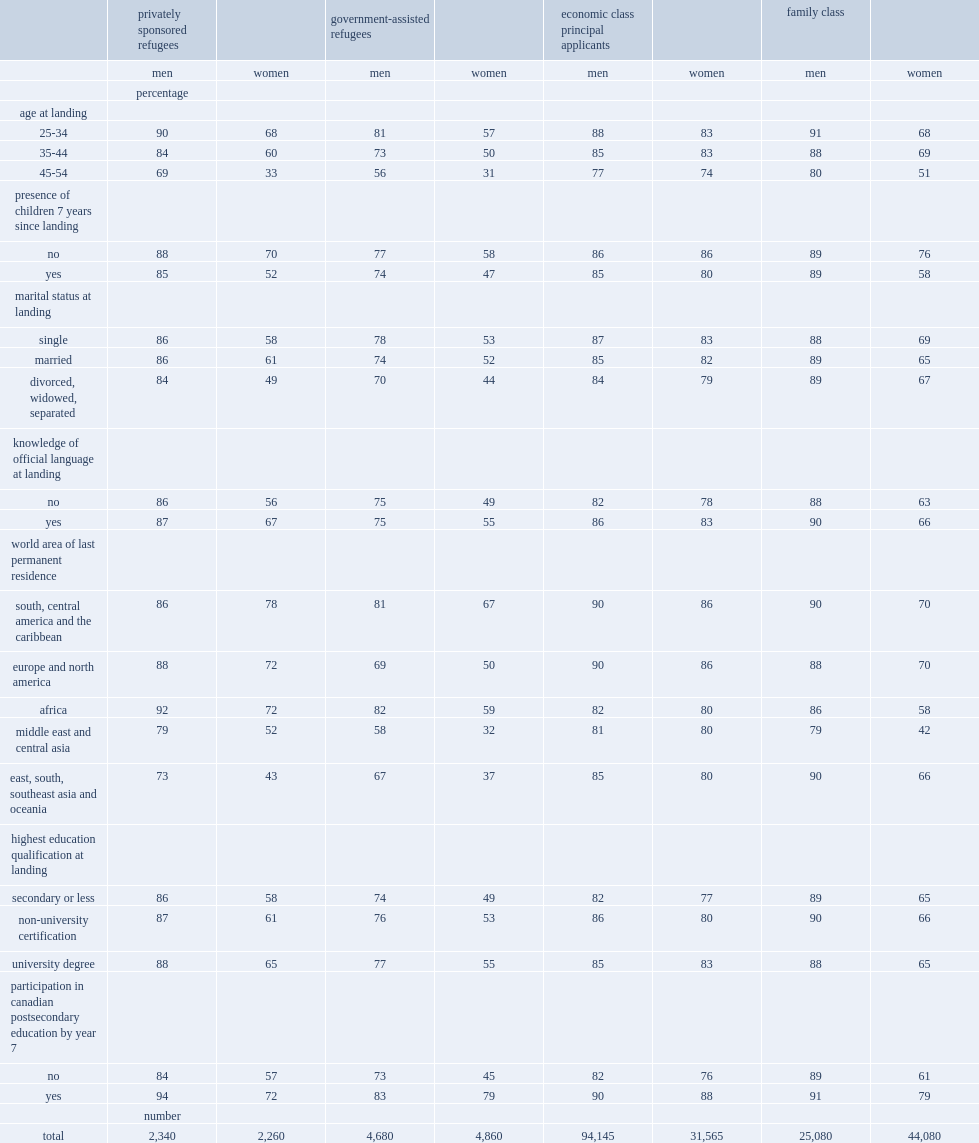What class of men has the smallest difference in the employment rate between the trained and the untrained, and what percentage is the difference? 2. 